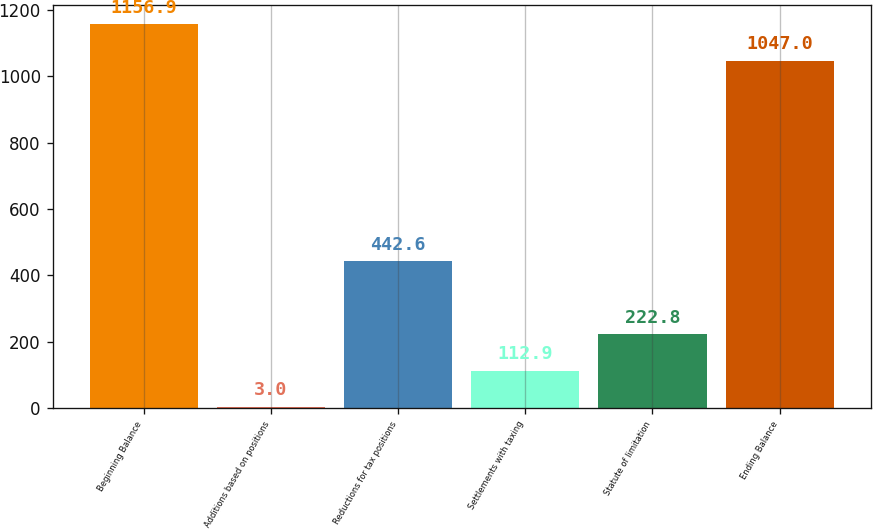<chart> <loc_0><loc_0><loc_500><loc_500><bar_chart><fcel>Beginning Balance<fcel>Additions based on positions<fcel>Reductions for tax positions<fcel>Settlements with taxing<fcel>Statute of limitation<fcel>Ending Balance<nl><fcel>1156.9<fcel>3<fcel>442.6<fcel>112.9<fcel>222.8<fcel>1047<nl></chart> 